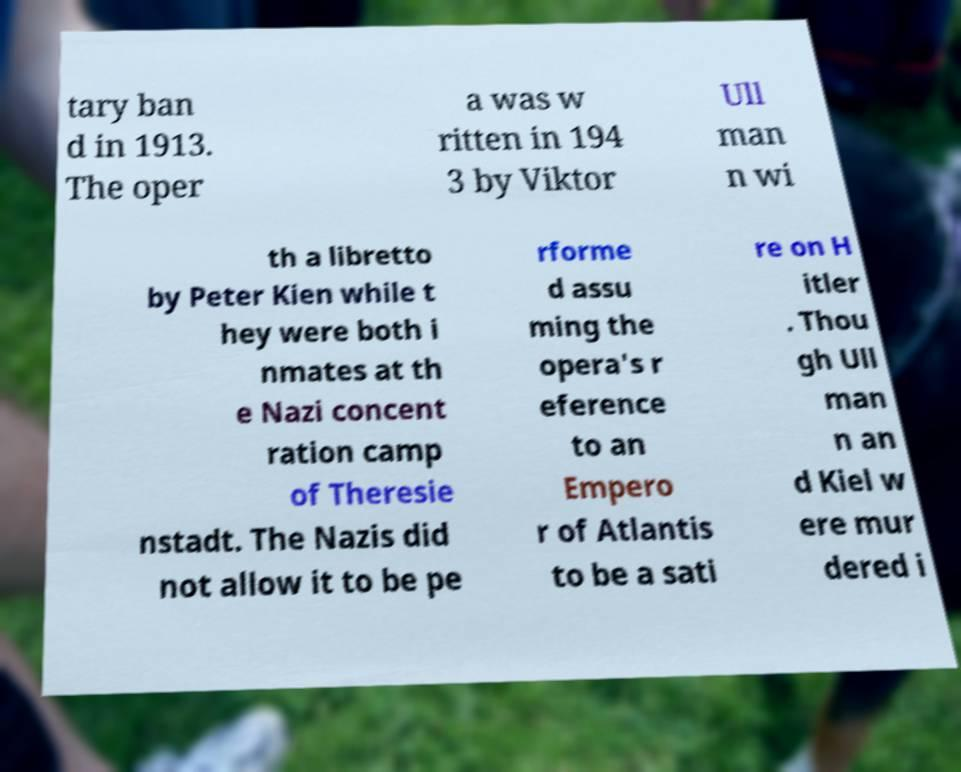Can you read and provide the text displayed in the image?This photo seems to have some interesting text. Can you extract and type it out for me? tary ban d in 1913. The oper a was w ritten in 194 3 by Viktor Ull man n wi th a libretto by Peter Kien while t hey were both i nmates at th e Nazi concent ration camp of Theresie nstadt. The Nazis did not allow it to be pe rforme d assu ming the opera's r eference to an Empero r of Atlantis to be a sati re on H itler . Thou gh Ull man n an d Kiel w ere mur dered i 